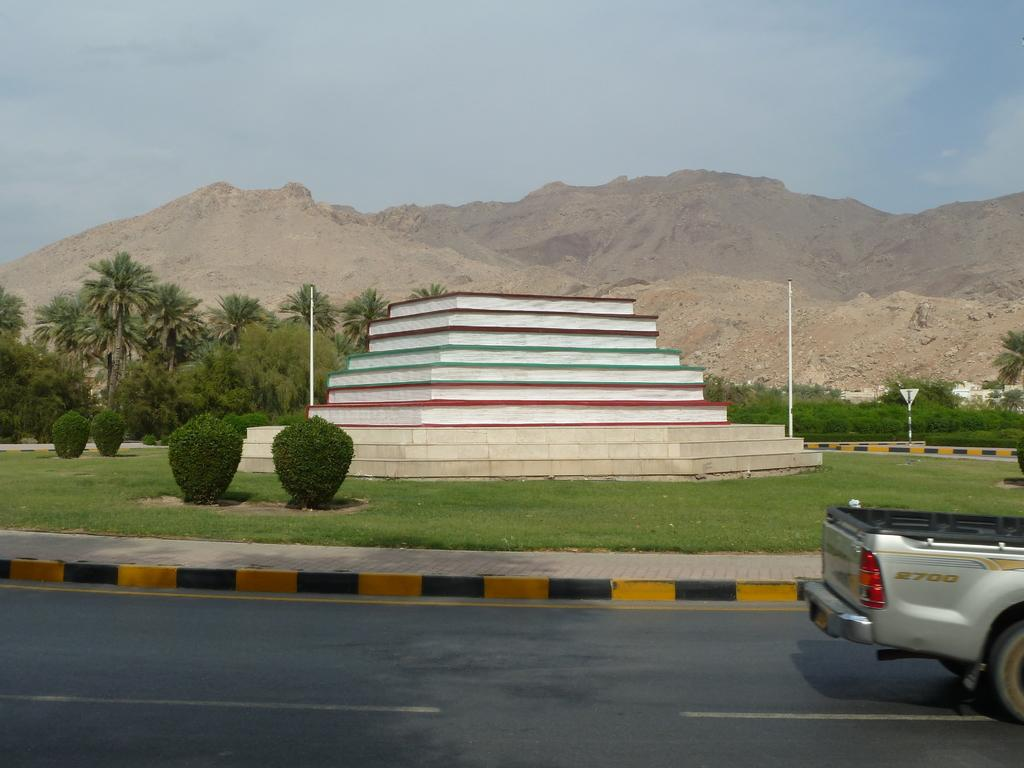<image>
Create a compact narrative representing the image presented. A pickup truck with 2700 on its side is partially visible in front of a pubic art piece. 